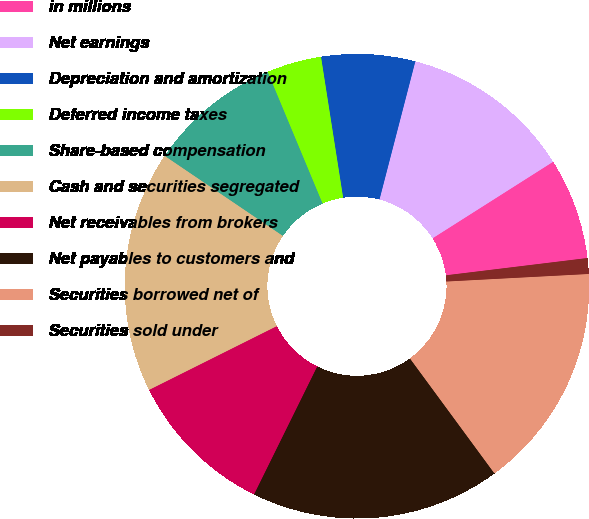Convert chart. <chart><loc_0><loc_0><loc_500><loc_500><pie_chart><fcel>in millions<fcel>Net earnings<fcel>Depreciation and amortization<fcel>Deferred income taxes<fcel>Share-based compensation<fcel>Cash and securities segregated<fcel>Net receivables from brokers<fcel>Net payables to customers and<fcel>Securities borrowed net of<fcel>Securities sold under<nl><fcel>7.07%<fcel>11.96%<fcel>6.52%<fcel>3.81%<fcel>9.24%<fcel>16.85%<fcel>10.33%<fcel>17.39%<fcel>15.76%<fcel>1.09%<nl></chart> 